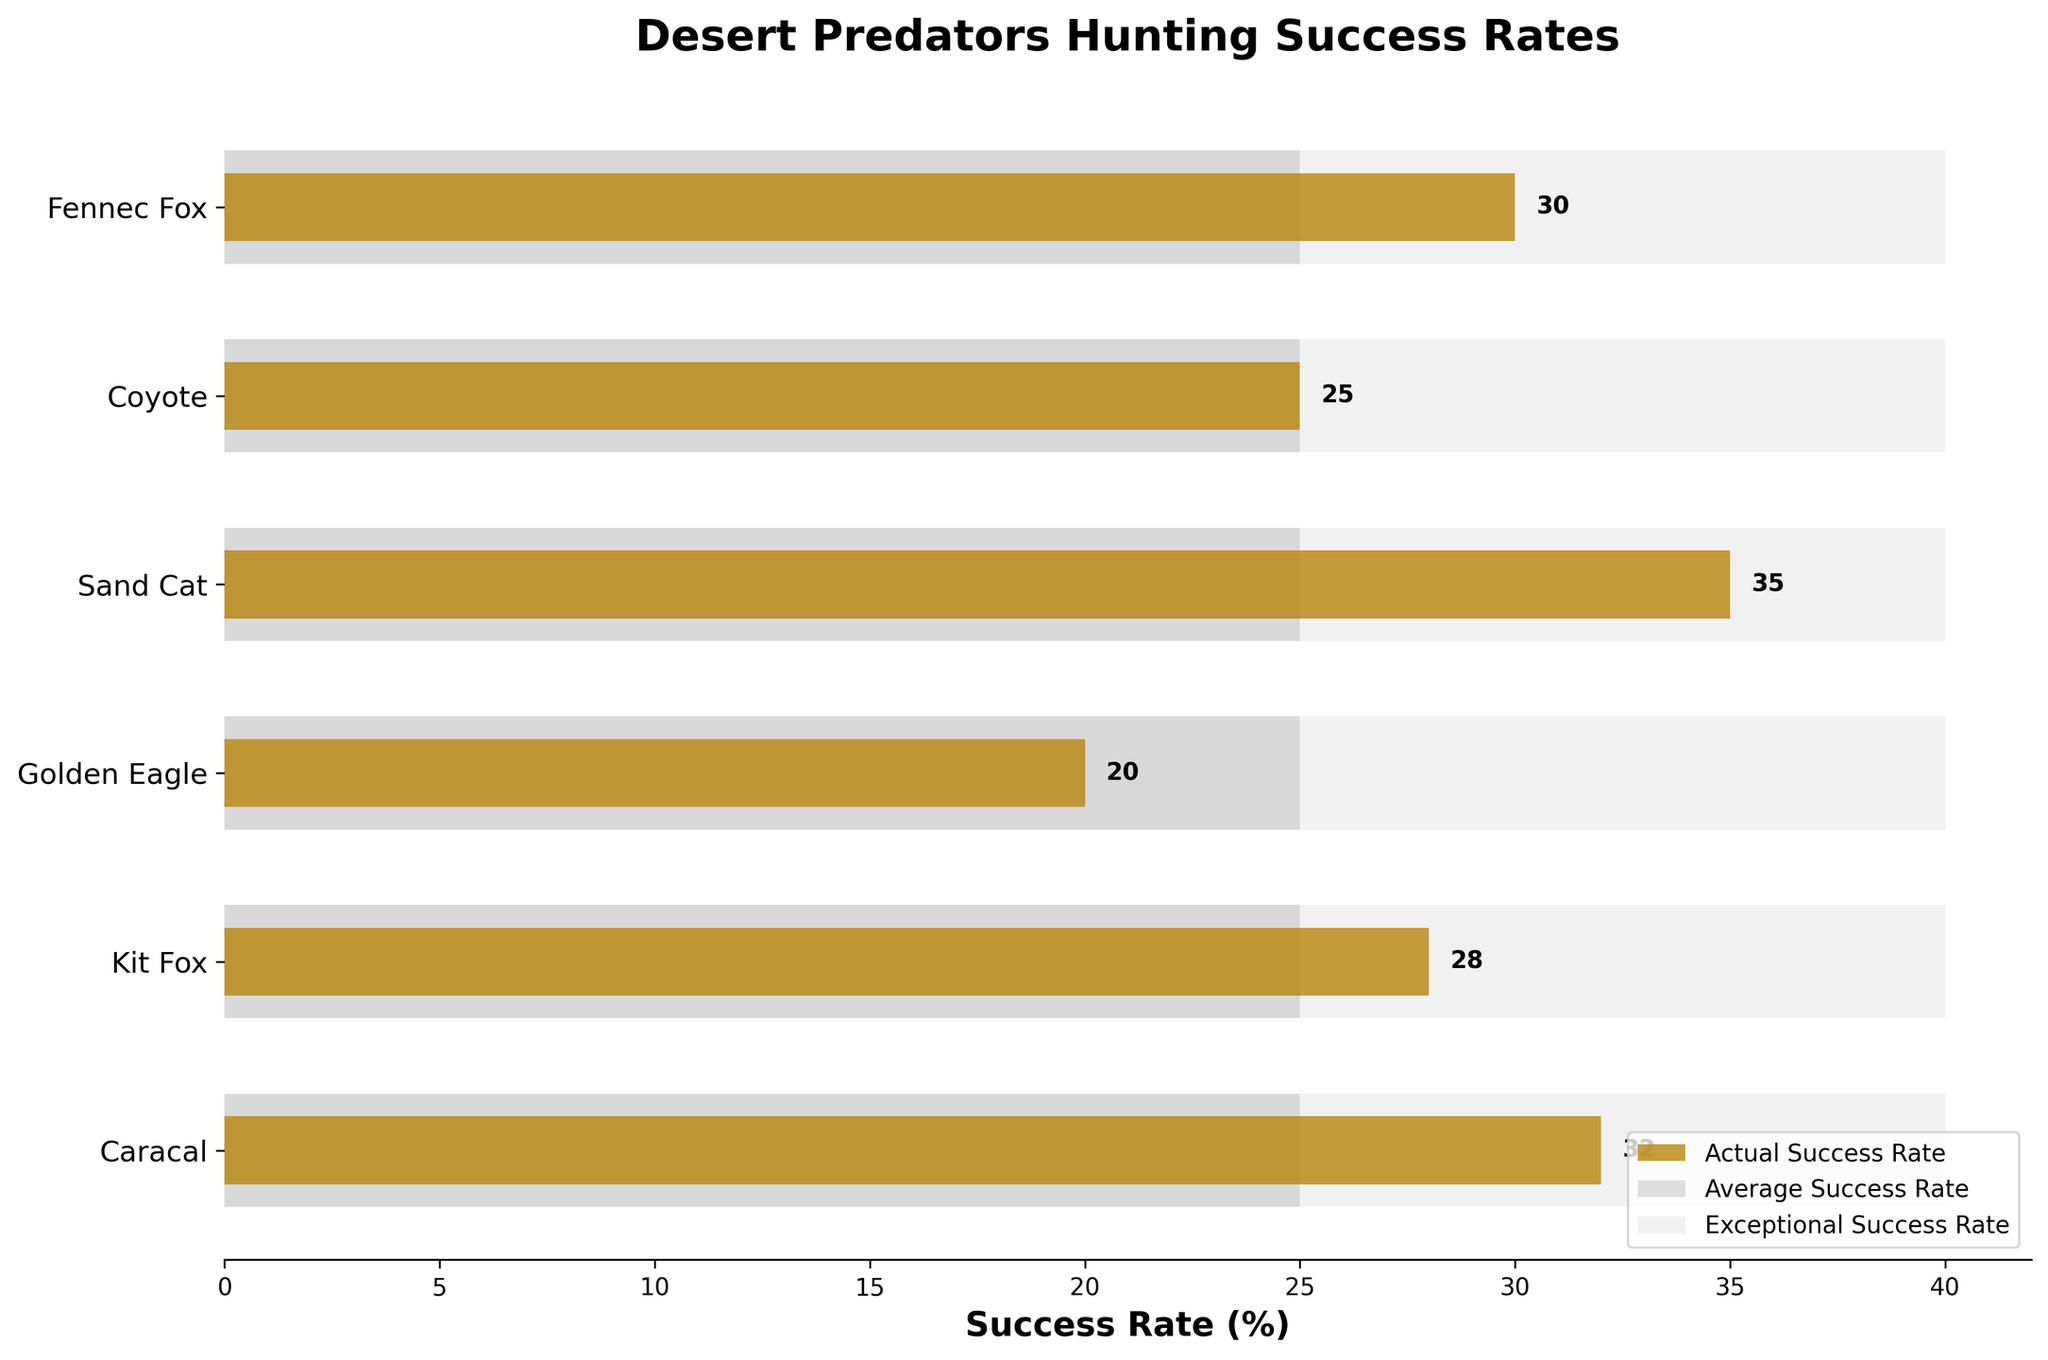What's the title of the figure? The title is usually located at the top of the figure, prominently displayed.
Answer: Desert Predators Hunting Success Rates Which desert predator has the lowest hunting success rate? By looking at the bars representing the hunting success rates, the shortest bar indicates the lowest success rate. This bar belongs to the Golden Eagle.
Answer: Golden Eagle Are there any predators with a hunting success rate higher than the average success rate? The average success rate is represented by the silver bars. By comparing each predator's actual success rate (the dark goldenrod bars) with the average, we can see which predators exceed this line. The Fennec Fox, Sand Cat, Caracal, and Kit Fox have hunting success rates higher than the average.
Answer: Fennec Fox, Sand Cat, Caracal, Kit Fox Which predator has the closest hunting success rate to the average? The average success rate is visually represented by the silver bars. The Coyote's dark goldenrod bar is almost perfectly aligned with the silver bar for the average rate.
Answer: Coyote How does the Fennec Fox's hunting success rate compare to the Kit Fox's? By visually comparing the dark goldenrod bars, we see that the Fennec Fox's bar (30%) is slightly higher than the Kit Fox's bar (28%).
Answer: Fennec Fox is higher What is the difference between the highest and lowest hunting success rates among the listed predators? The highest success rate is 35% (Sand Cat), and the lowest is 20% (Golden Eagle). The difference is 35% - 20%.
Answer: 15% Which predator has a success rate closest to 30%? The bars corresponding to each success rate can be checked, and the Fennec Fox has a success rate of 30%, which exactly matches the value.
Answer: Fennec Fox If the exceptional success rate is 40%, which predators' actual success rates fall below this mark? The exceptional success rate is represented by the light gray bars, set at 40%. Predators with their dark goldenrod bars below this mark are Fennec Fox, Coyote, Sand Cat, Golden Eagle, Kit Fox, and Caracal, meaning all listed predators fall below this mark.
Answer: All listed predators How many predators have a hunting success rate above 30%? By looking at the dark goldenrod bars, we identify Fennec Fox (30%), Sand Cat (35%), Caracal (32%), and Kit Fox (28%). Only Sand Cat and Caracal are above 30%.
Answer: 2 What is the average hunting success rate for all the predators combined? Add up all the success rates: (30 + 25 + 35 + 20 + 28 + 32) and divide by the number of predators (6). Total is 170, and 170/6 = 28.33%.
Answer: 28.33% 